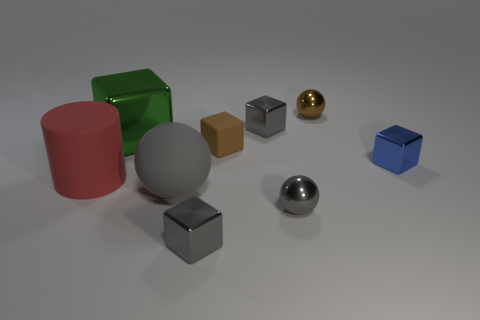Is there a tiny rubber cube of the same color as the big metal thing?
Your answer should be compact. No. What shape is the big object that is to the right of the red rubber cylinder and in front of the large green metal cube?
Provide a succinct answer. Sphere. What number of gray things are the same material as the tiny brown cube?
Your answer should be compact. 1. Are there fewer blue blocks behind the green shiny block than small blue metallic things to the left of the red cylinder?
Your response must be concise. No. What material is the brown object to the right of the gray sphere to the right of the small metal block that is behind the blue metal block made of?
Offer a terse response. Metal. There is a matte thing that is both in front of the small matte object and right of the red matte cylinder; how big is it?
Ensure brevity in your answer.  Large. How many spheres are either tiny brown rubber objects or big gray metallic objects?
Provide a succinct answer. 0. The other rubber object that is the same size as the red object is what color?
Your answer should be compact. Gray. Is there any other thing that has the same shape as the green object?
Offer a very short reply. Yes. What color is the other big thing that is the same shape as the blue object?
Offer a very short reply. Green. 